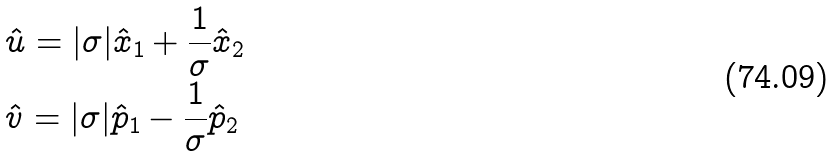Convert formula to latex. <formula><loc_0><loc_0><loc_500><loc_500>& \hat { u } = | \sigma | \hat { x } _ { 1 } + \frac { 1 } { \sigma } \hat { x } _ { 2 } \\ & \hat { v } = | \sigma | \hat { p } _ { 1 } - \frac { 1 } { \sigma } \hat { p } _ { 2 }</formula> 